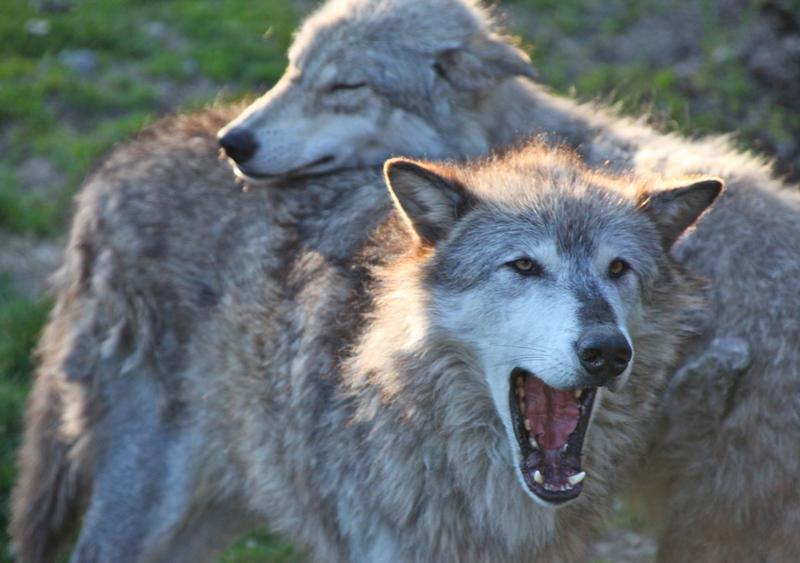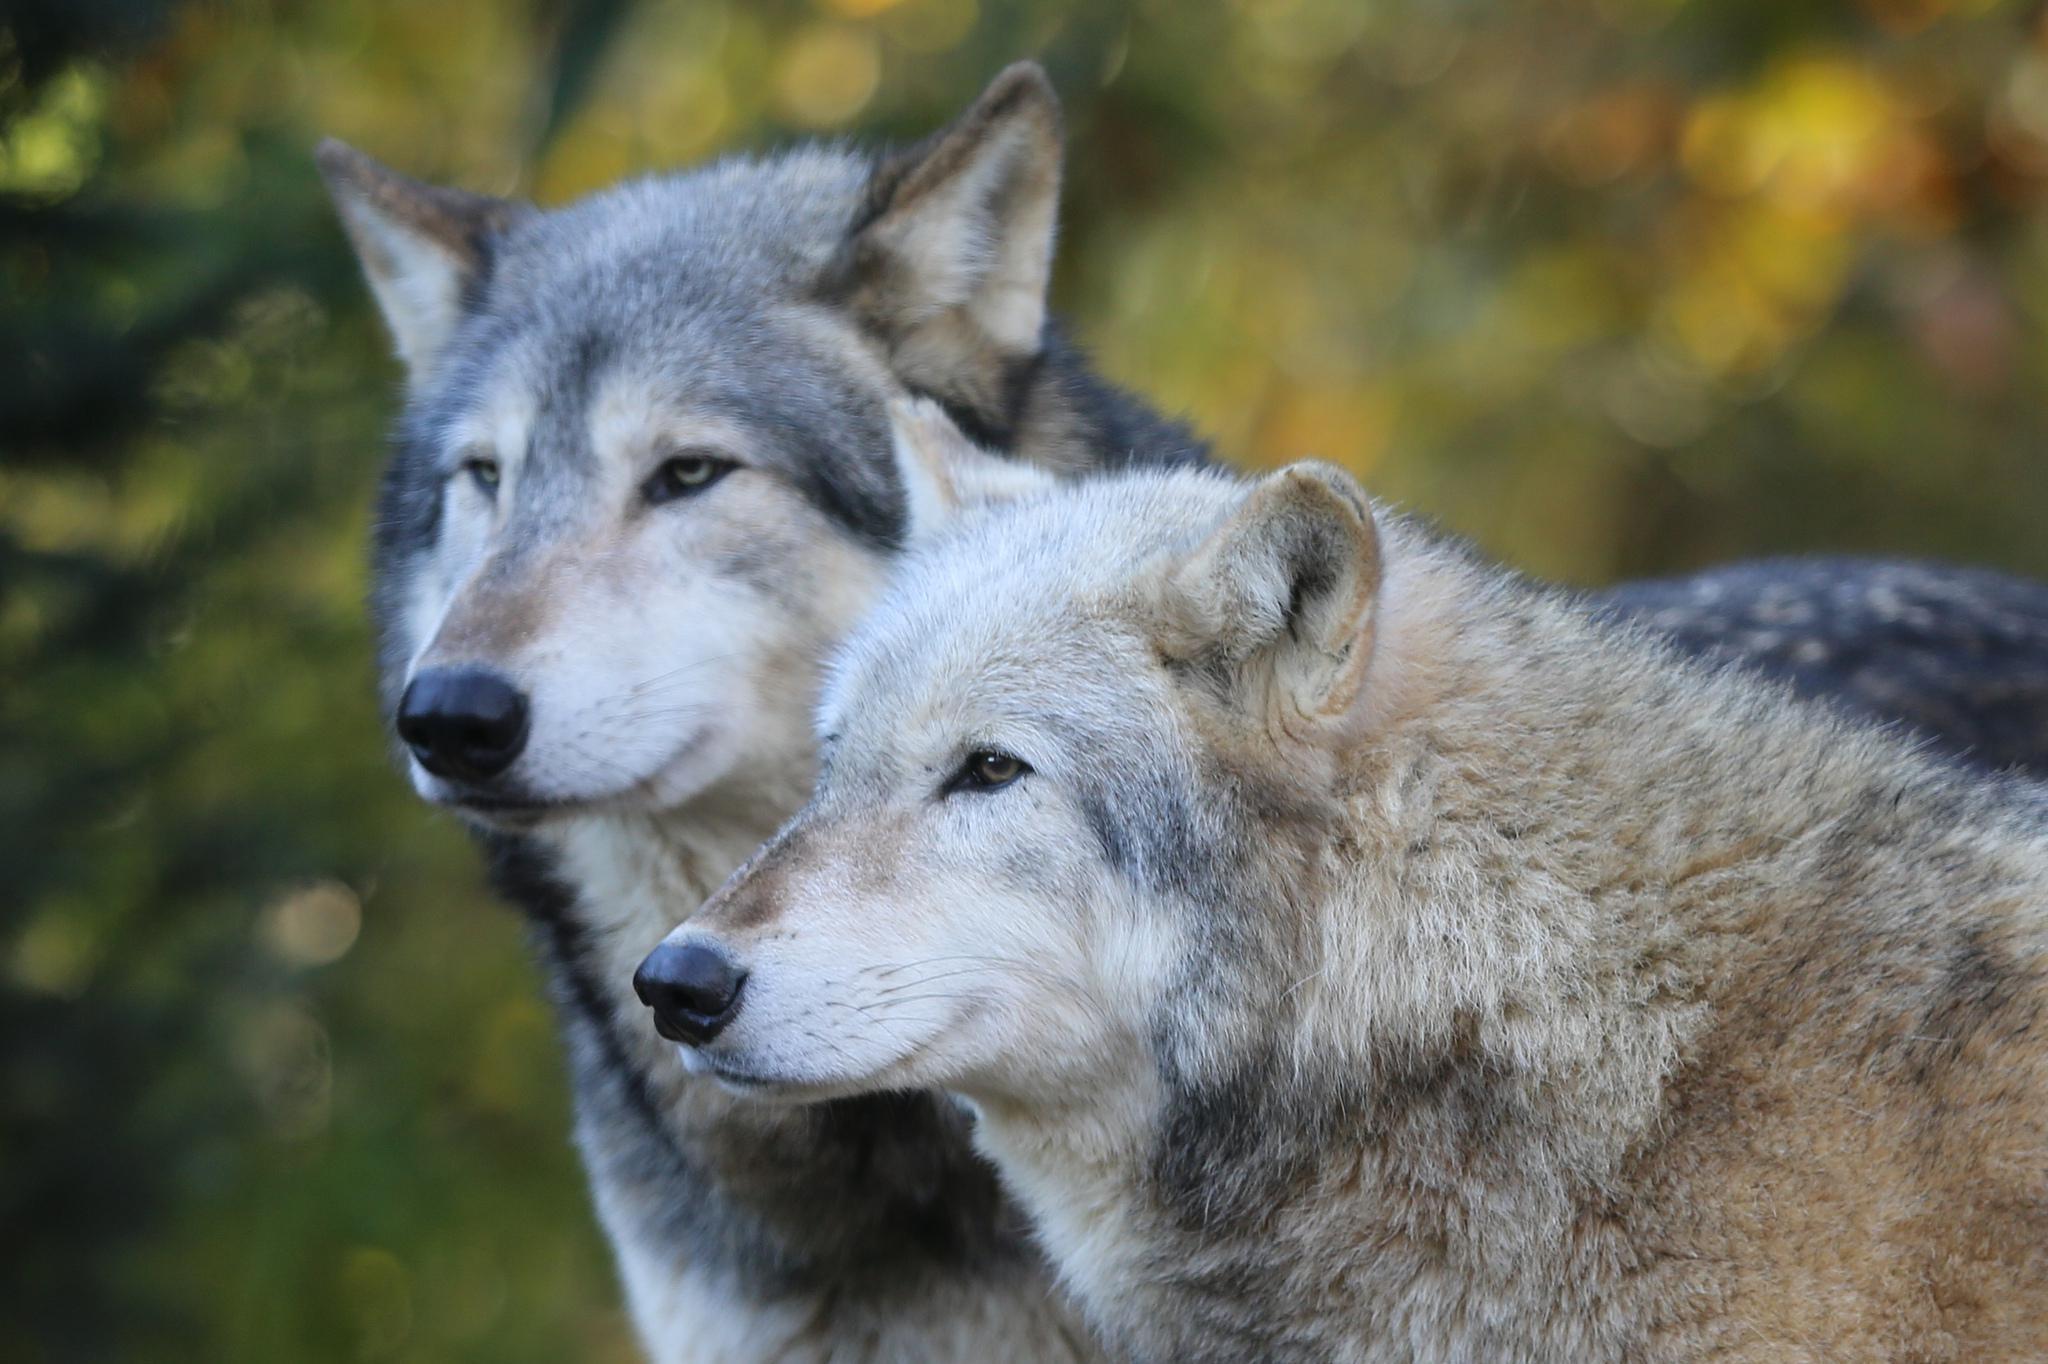The first image is the image on the left, the second image is the image on the right. Evaluate the accuracy of this statement regarding the images: "There are exactly four wolves in total.". Is it true? Answer yes or no. Yes. The first image is the image on the left, the second image is the image on the right. Analyze the images presented: Is the assertion "The left image shows exactly two wolves, at least one with its mouth open and at least one with its eyes shut." valid? Answer yes or no. Yes. 